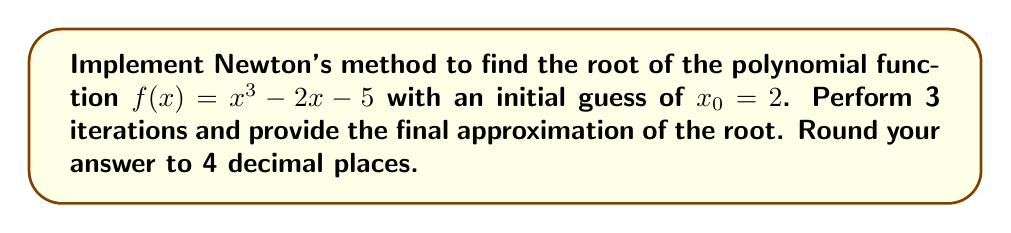Show me your answer to this math problem. Newton's method is an iterative algorithm for finding roots of a function. For a polynomial function $f(x)$, the iterative formula is:

$$x_{n+1} = x_n - \frac{f(x_n)}{f'(x_n)}$$

where $f'(x)$ is the derivative of $f(x)$.

Step 1: Calculate $f'(x)$
$f(x) = x^3 - 2x - 5$
$f'(x) = 3x^2 - 2$

Step 2: Implement the iterative formula
$x_{n+1} = x_n - \frac{x_n^3 - 2x_n - 5}{3x_n^2 - 2}$

Step 3: Perform 3 iterations

Iteration 1:
$x_1 = 2 - \frac{2^3 - 2(2) - 5}{3(2)^2 - 2} = 2 - \frac{-1}{10} = 2.1$

Iteration 2:
$x_2 = 2.1 - \frac{2.1^3 - 2(2.1) - 5}{3(2.1)^2 - 2} \approx 2.0946$

Iteration 3:
$x_3 = 2.0946 - \frac{2.0946^3 - 2(2.0946) - 5}{3(2.0946)^2 - 2} \approx 2.0941$

Step 4: Round the final approximation to 4 decimal places
2.0941
Answer: 2.0941 